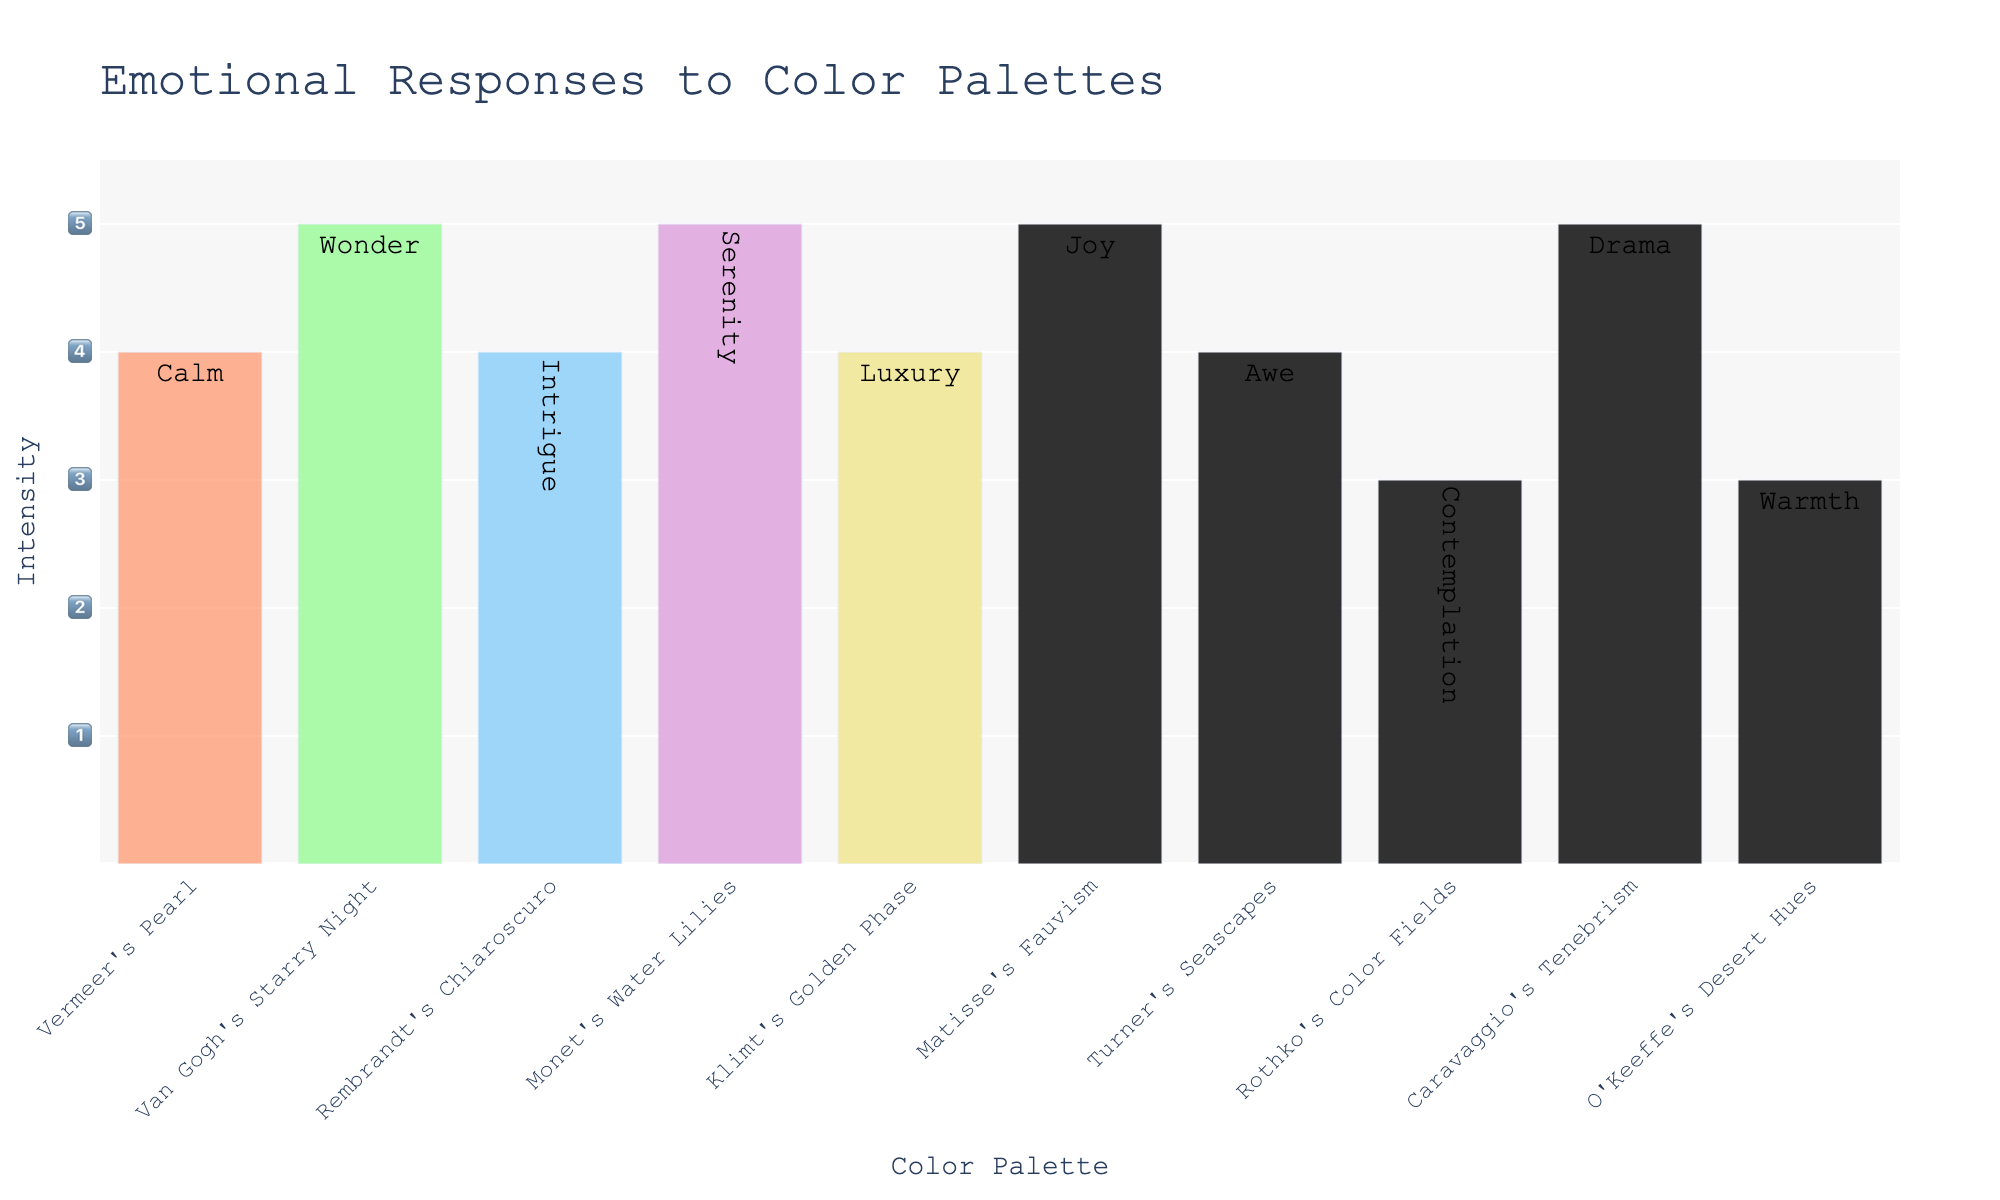What's the title of the figure? The title of a figure is usually located at the top. Here, the title is prominently displayed at the top center of the plot.
Answer: Emotional Responses to Color Palettes Which color palette has the highest intensity level? Look at the y-axis intensity levels and see which bar reaches the highest point. For Van Gogh's Starry Night, the bar reaches the highest point on the plot.
Answer: Van Gogh's Starry Night What is the intensity of the emotion 'Joy'? Locate the 'Joy' emotion in the text inside the bars. The bar for Matisse's Fauvism has 'Joy' with the intensity of 5.
Answer: 5 Which color palettes evoke emotions with an intensity of 4? Check the bars that reach the intensity level marked as 4 on the y-axis. Vermeer's Pearl, Rembrandt's Chiaroscuro, Klimt's Golden Phase, and Turner's Seascapes have an intensity of 4.
Answer: Vermeer's Pearl, Rembrandt's Chiaroscuro, Klimt's Golden Phase, Turner's Seascapes What is the average intensity of emotions across all color palettes? Sum all intensity values and then divide by the number of color palettes. The sum is (4+5+4+5+4+5+4+3+5+3) = 42 and there are 10 palettes. The average is 42 / 10 = 4.2
Answer: 4.2 How many color palettes evoke an emotion with an intensity of 5? Count the number of bars that reach the intensity level marked as 5 on the y-axis. There are four such bars: Van Gogh's Starry Night, Monet's Water Lilies, Matisse's Fauvism, and Caravaggio's Tenebrism.
Answer: 4 Which emotion is associated with Rothko's Color Fields? Find the bar labeled Rothko's Color Fields and look at the text inside it. The emotion listed is 'Contemplation'.
Answer: Contemplation Compare the intensity between Turner's Seascapes and O'Keeffe's Desert Hues. Which is greater? Locate the bars for both Turner's Seascapes and O'Keeffe's Desert Hues. Turner's Seascapes has an intensity of 4 while O'Keeffe's Desert Hues has an intensity of 3. Therefore, Turner's Seascapes is greater.
Answer: Turner's Seascapes What is the range of intensity values in the figure? Identify the lowest and highest intensity values shown on the y-axis. The values range from 3 to 5.
Answer: 3 to 5 